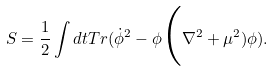<formula> <loc_0><loc_0><loc_500><loc_500>S = \frac { 1 } { 2 } \int d t T r ( \dot { \phi } ^ { 2 } - \phi \Big ( \nabla ^ { 2 } + { \mu } ^ { 2 } ) \phi ) .</formula> 